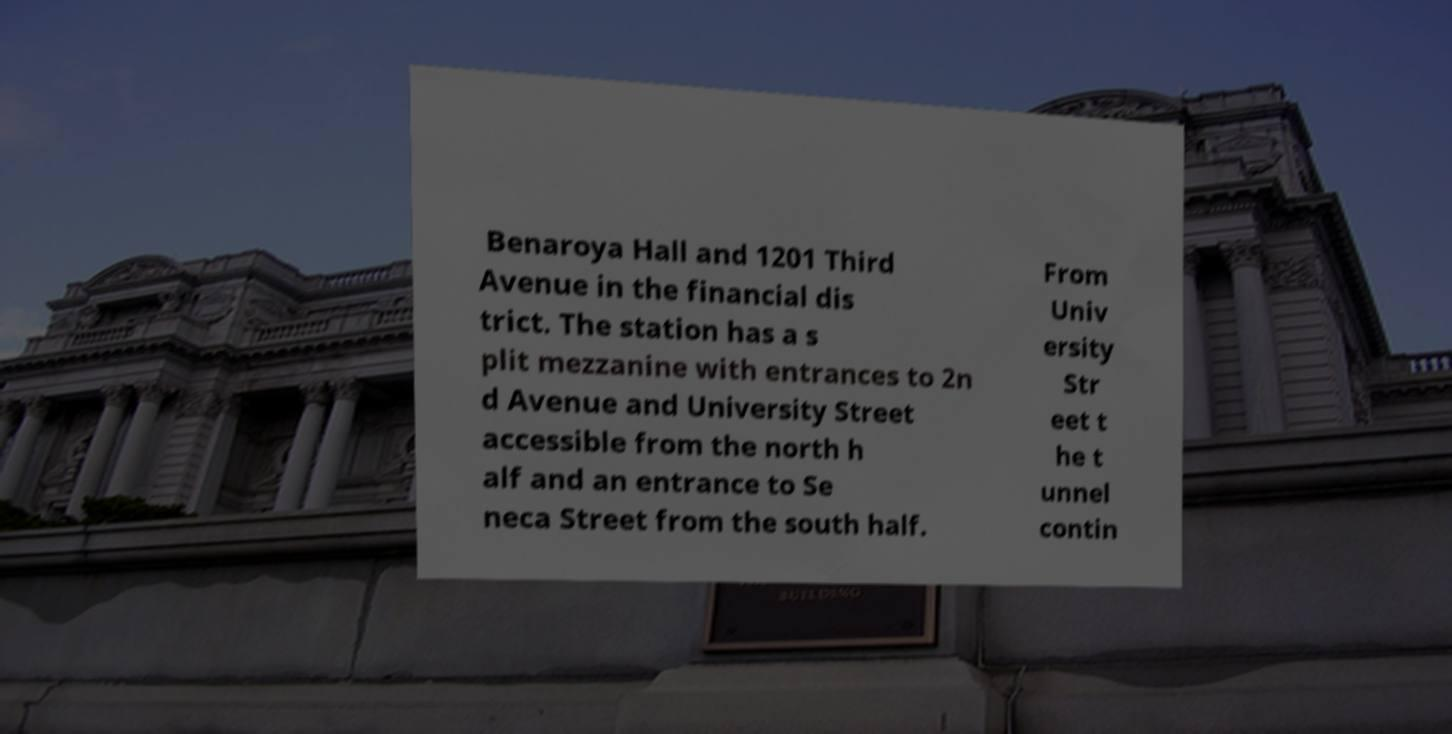What messages or text are displayed in this image? I need them in a readable, typed format. Benaroya Hall and 1201 Third Avenue in the financial dis trict. The station has a s plit mezzanine with entrances to 2n d Avenue and University Street accessible from the north h alf and an entrance to Se neca Street from the south half. From Univ ersity Str eet t he t unnel contin 